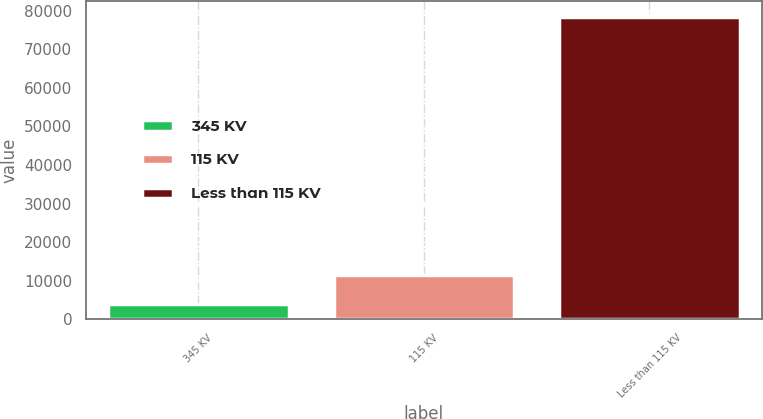<chart> <loc_0><loc_0><loc_500><loc_500><bar_chart><fcel>345 KV<fcel>115 KV<fcel>Less than 115 KV<nl><fcel>4062<fcel>11500.4<fcel>78446<nl></chart> 